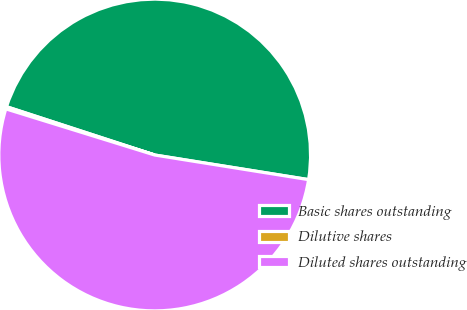Convert chart. <chart><loc_0><loc_0><loc_500><loc_500><pie_chart><fcel>Basic shares outstanding<fcel>Dilutive shares<fcel>Diluted shares outstanding<nl><fcel>47.51%<fcel>0.23%<fcel>52.26%<nl></chart> 